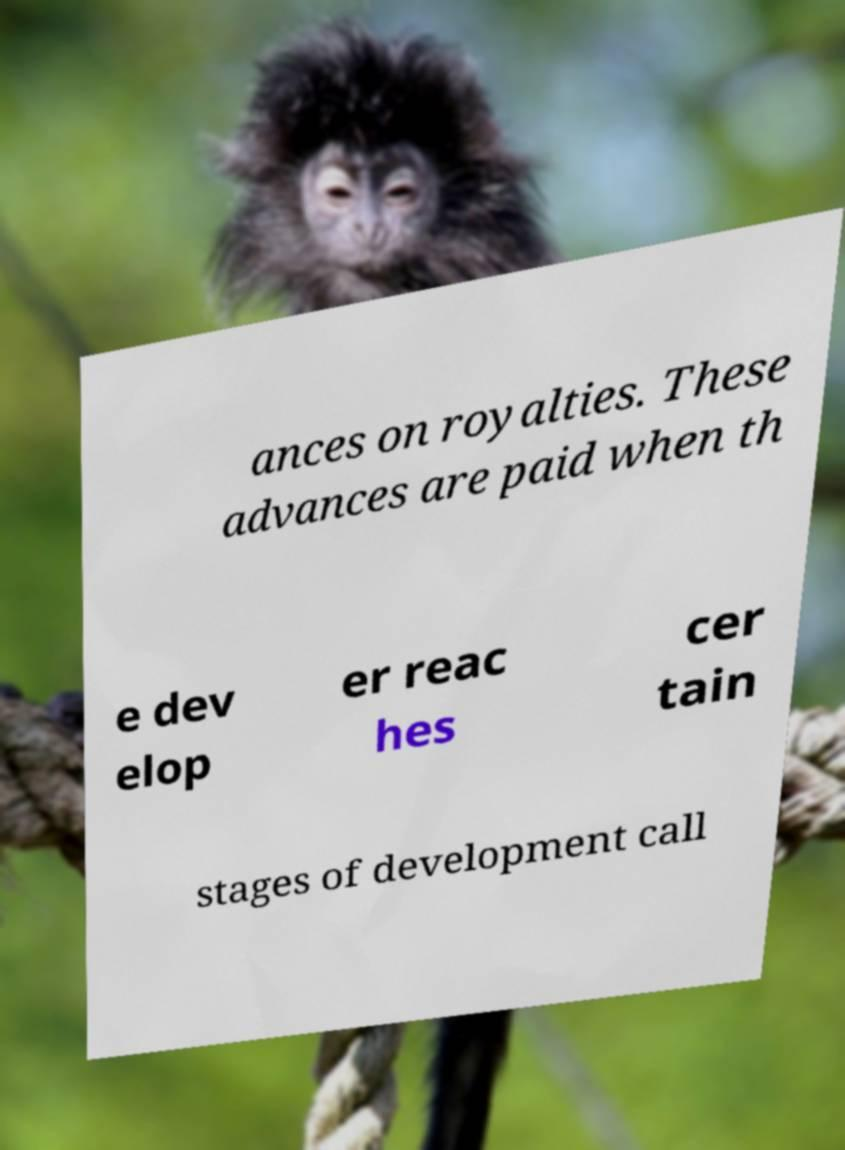What messages or text are displayed in this image? I need them in a readable, typed format. ances on royalties. These advances are paid when th e dev elop er reac hes cer tain stages of development call 